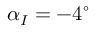Convert formula to latex. <formula><loc_0><loc_0><loc_500><loc_500>\alpha _ { I } = - 4 ^ { \circ }</formula> 